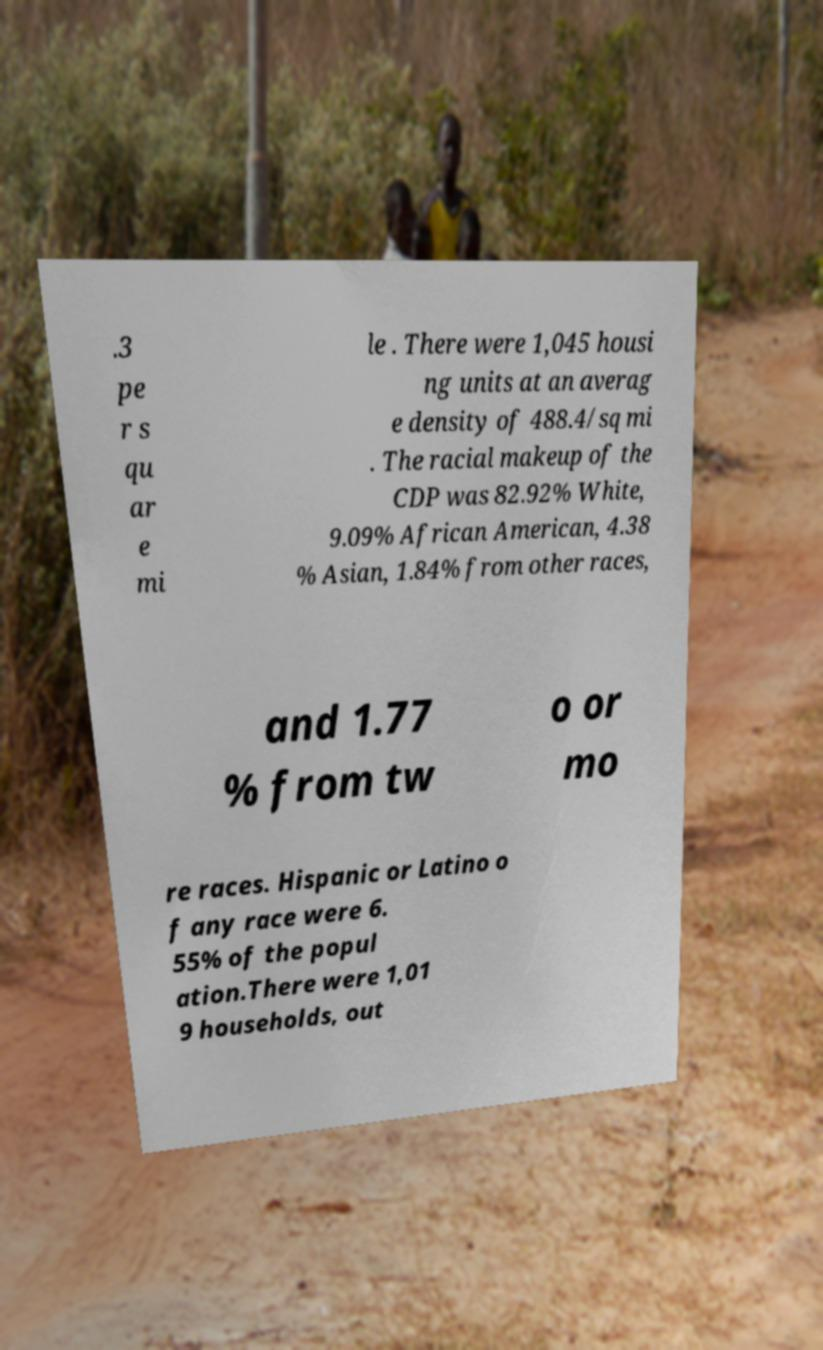Can you accurately transcribe the text from the provided image for me? .3 pe r s qu ar e mi le . There were 1,045 housi ng units at an averag e density of 488.4/sq mi . The racial makeup of the CDP was 82.92% White, 9.09% African American, 4.38 % Asian, 1.84% from other races, and 1.77 % from tw o or mo re races. Hispanic or Latino o f any race were 6. 55% of the popul ation.There were 1,01 9 households, out 